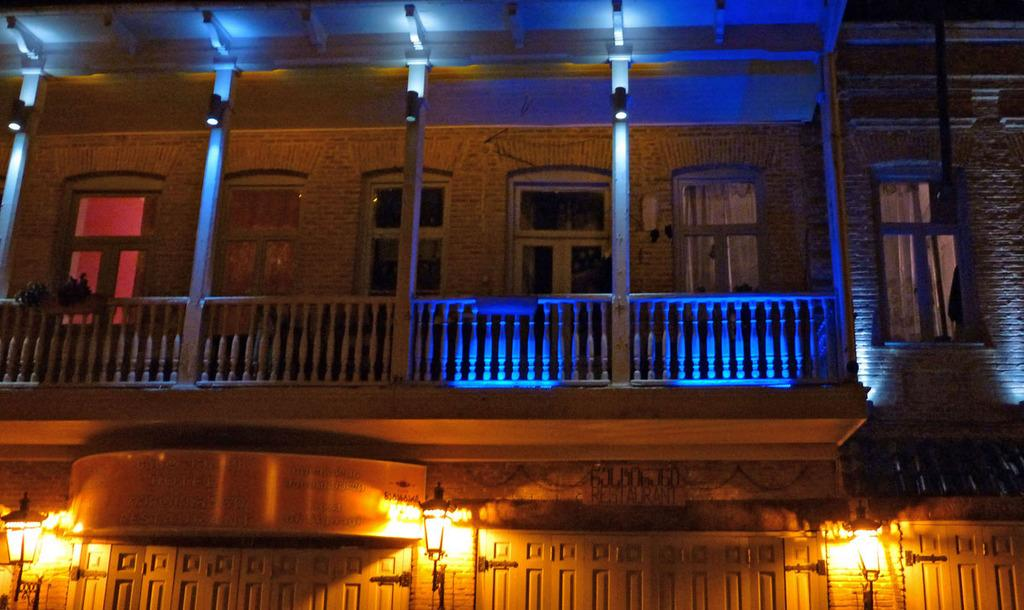What type of structure is present in the image? There is a building in the image. What feature can be seen near the building? There is a railing in the image. What object is visible in the image that might have information or instructions? There is a board in the image. What can be seen providing illumination in the image? There are lights in the image. What architectural element is present in the building? There are windows in the image. What vertical structures are present in the image? There are poles in the image. What year is depicted on the bridge in the image? There is no bridge present in the image, so the year cannot be determined. How many spiders are crawling on the windows in the image? There are no spiders present in the image; only the building, railing, board, lights, windows, and poles are visible. 